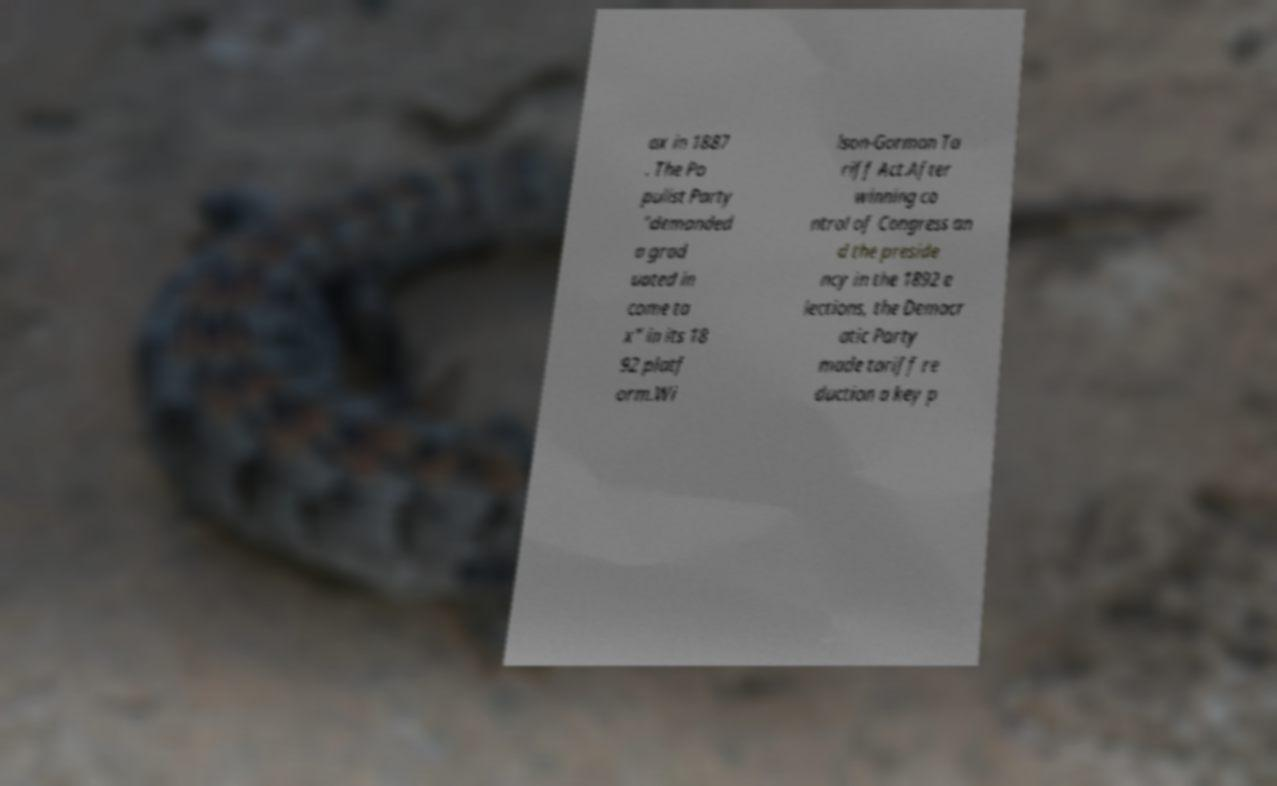Please read and relay the text visible in this image. What does it say? ax in 1887 . The Po pulist Party "demanded a grad uated in come ta x" in its 18 92 platf orm.Wi lson-Gorman Ta riff Act.After winning co ntrol of Congress an d the preside ncy in the 1892 e lections, the Democr atic Party made tariff re duction a key p 